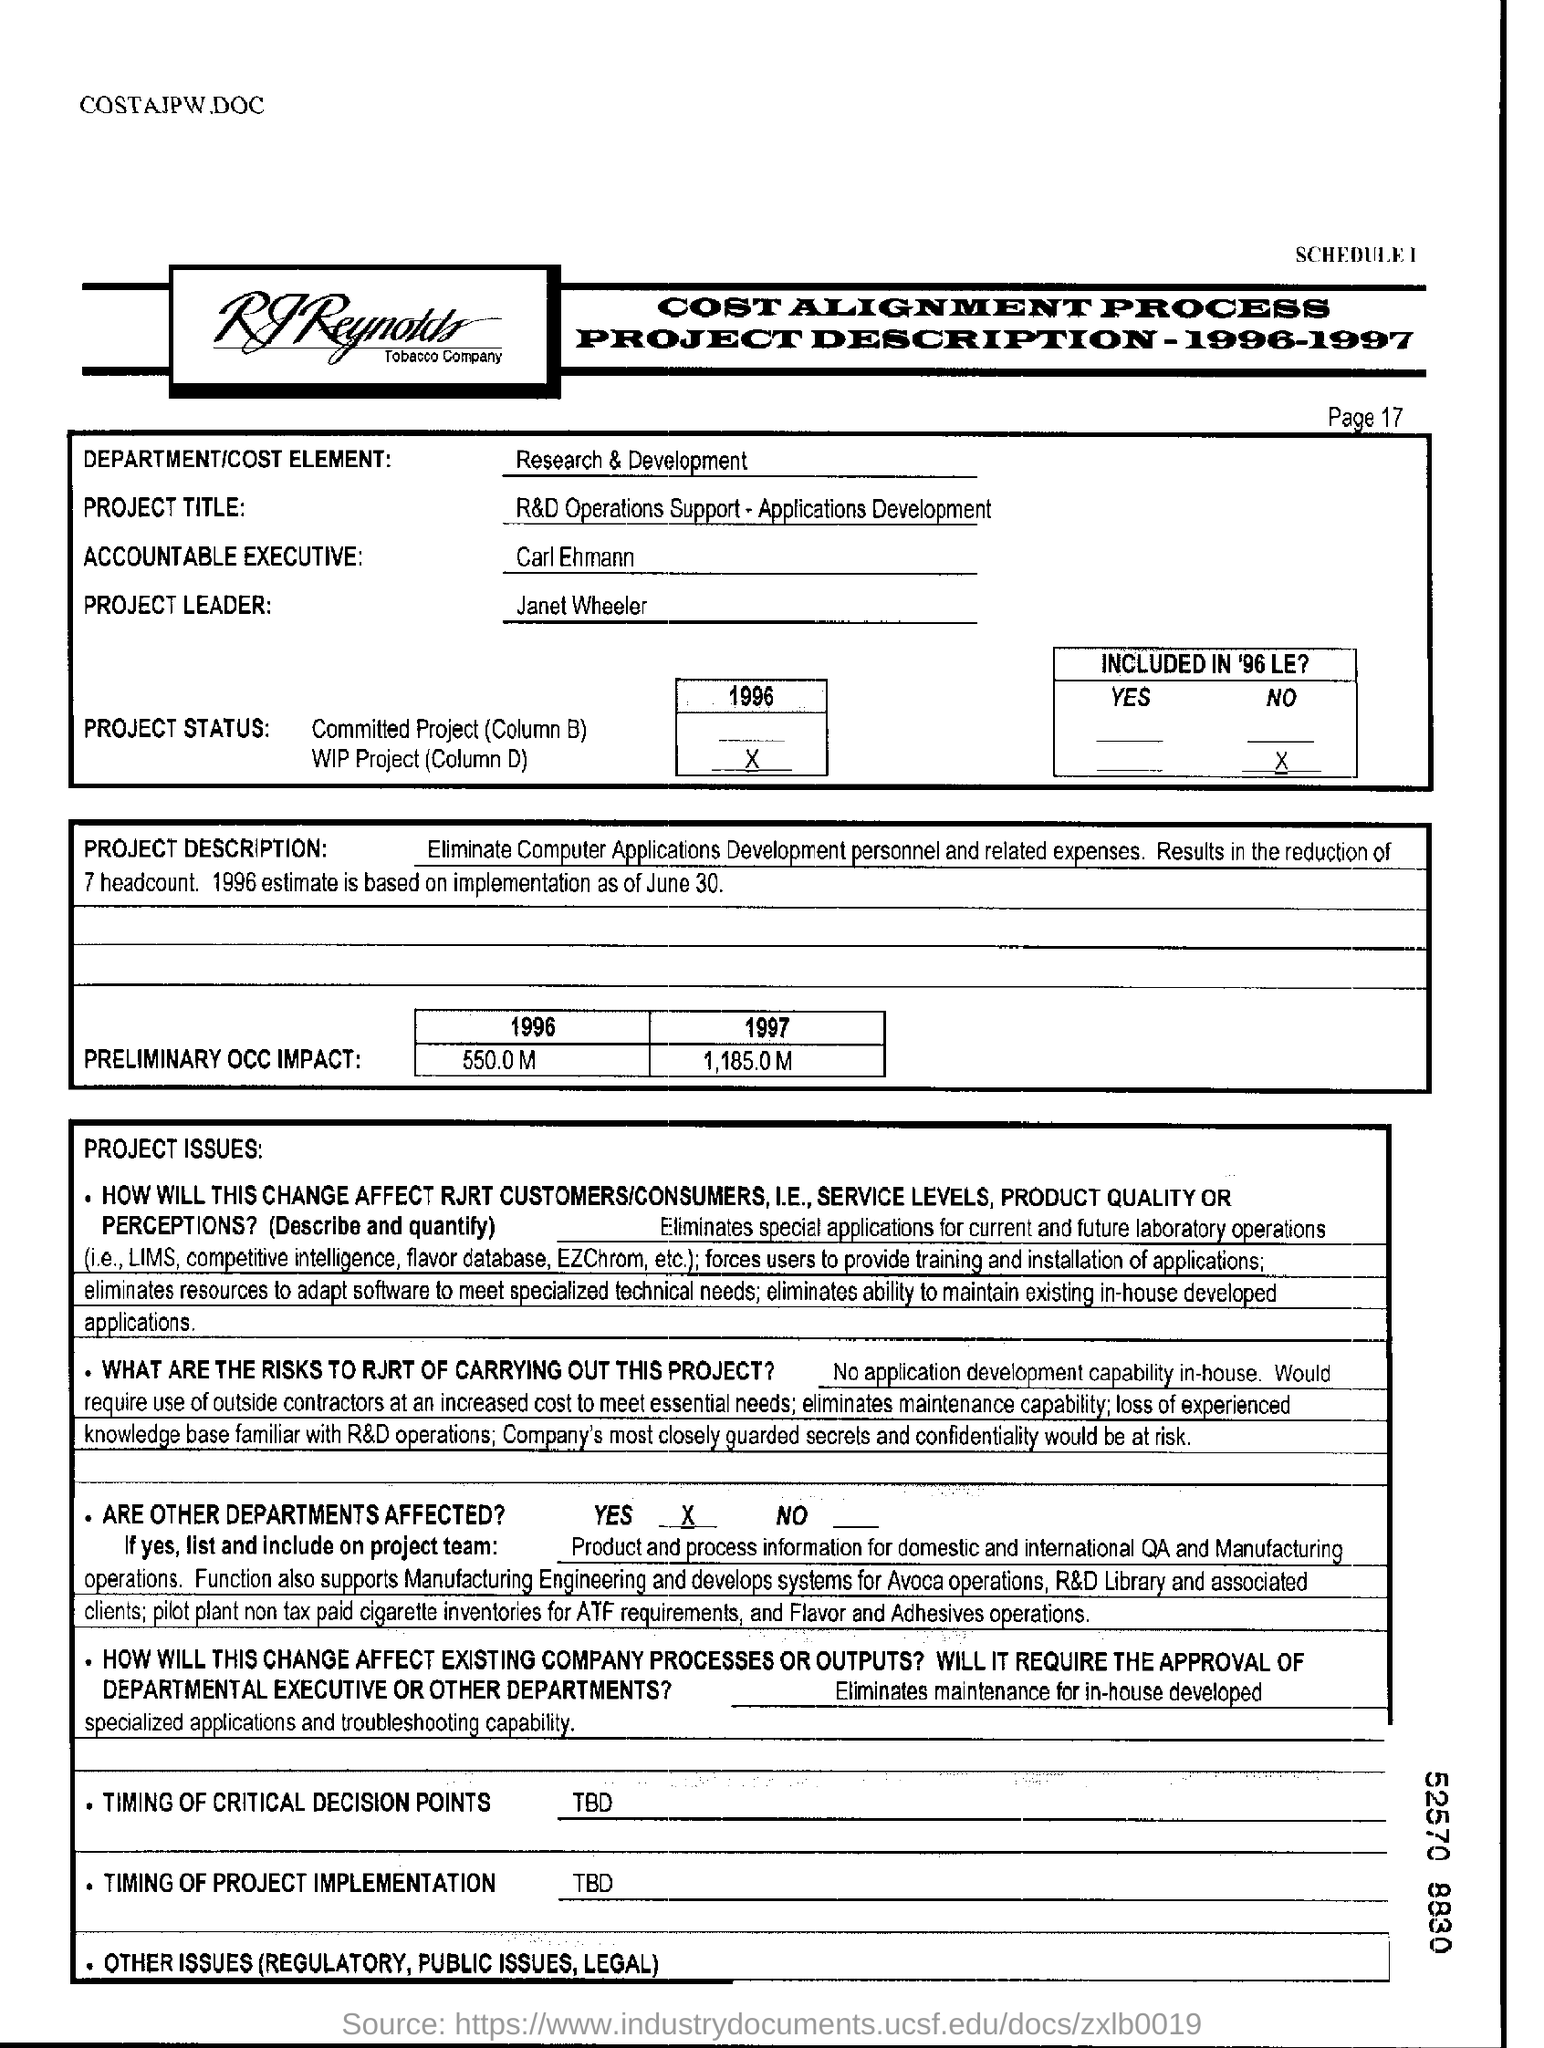Indicate a few pertinent items in this graphic. The estimated initial impact of the Premliminary Occ (Premature Ovarian Insufficiency) in the year 1996 was 550.0 million. The date mentioned in the document is June 30. Carl Ehmann is the accountable executive. In the year 1997, the preliminary estimated impact of the OCC (Office of the Comptroller of the Currency) was 1,185.0 million. The project leader is Janet Wheeler. 